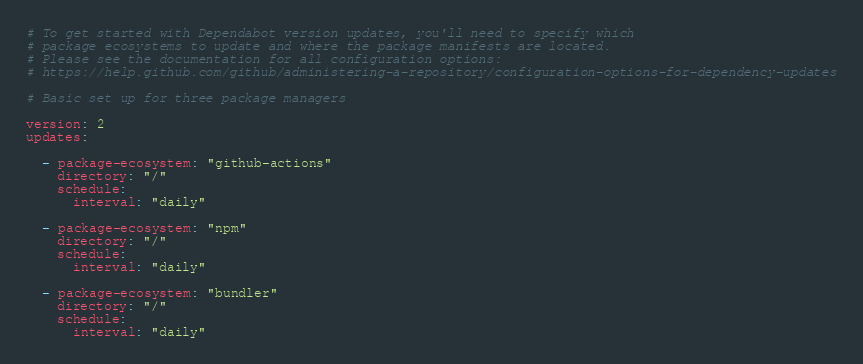Convert code to text. <code><loc_0><loc_0><loc_500><loc_500><_YAML_># To get started with Dependabot version updates, you'll need to specify which
# package ecosystems to update and where the package manifests are located.
# Please see the documentation for all configuration options:
# https://help.github.com/github/administering-a-repository/configuration-options-for-dependency-updates

# Basic set up for three package managers

version: 2
updates:

  - package-ecosystem: "github-actions"
    directory: "/"
    schedule:
      interval: "daily"

  - package-ecosystem: "npm"
    directory: "/"
    schedule:
      interval: "daily"

  - package-ecosystem: "bundler"
    directory: "/"
    schedule:
      interval: "daily"
</code> 